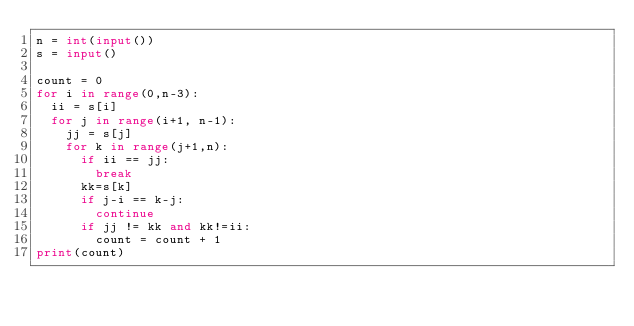Convert code to text. <code><loc_0><loc_0><loc_500><loc_500><_Python_>n = int(input())
s = input()

count = 0
for i in range(0,n-3):
  ii = s[i]
  for j in range(i+1, n-1):
    jj = s[j]
    for k in range(j+1,n):
      if ii == jj:
        break
      kk=s[k]
      if j-i == k-j:
        continue
      if jj != kk and kk!=ii:
        count = count + 1
print(count)
</code> 